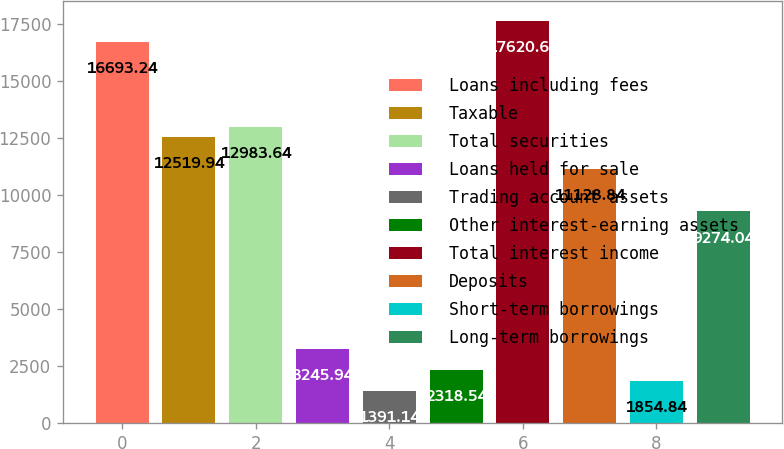<chart> <loc_0><loc_0><loc_500><loc_500><bar_chart><fcel>Loans including fees<fcel>Taxable<fcel>Total securities<fcel>Loans held for sale<fcel>Trading account assets<fcel>Other interest-earning assets<fcel>Total interest income<fcel>Deposits<fcel>Short-term borrowings<fcel>Long-term borrowings<nl><fcel>16693.2<fcel>12519.9<fcel>12983.6<fcel>3245.94<fcel>1391.14<fcel>2318.54<fcel>17620.6<fcel>11128.8<fcel>1854.84<fcel>9274.04<nl></chart> 